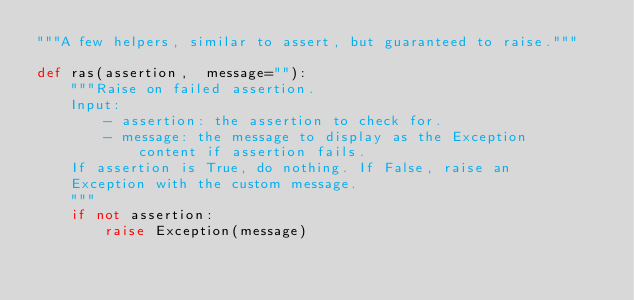Convert code to text. <code><loc_0><loc_0><loc_500><loc_500><_Python_>"""A few helpers, similar to assert, but guaranteed to raise."""

def ras(assertion,  message=""):
    """Raise on failed assertion.
    Input:
        - assertion: the assertion to check for.
        - message: the message to display as the Exception
            content if assertion fails.
    If assertion is True, do nothing. If False, raise an
    Exception with the custom message.
    """
    if not assertion:
        raise Exception(message)
</code> 